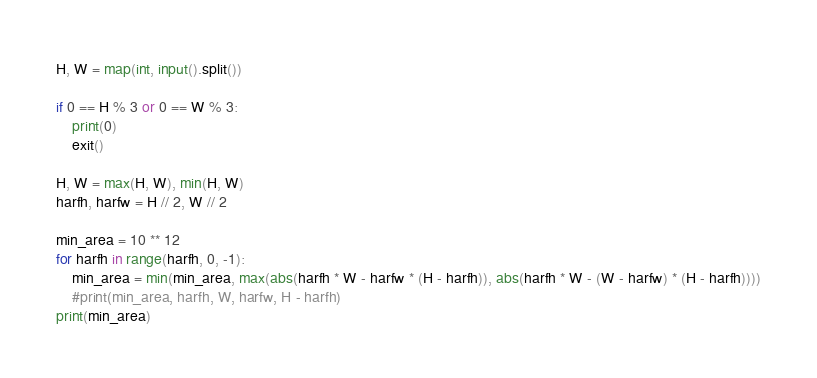Convert code to text. <code><loc_0><loc_0><loc_500><loc_500><_Python_>H, W = map(int, input().split())

if 0 == H % 3 or 0 == W % 3:
	print(0)
	exit()

H, W = max(H, W), min(H, W)
harfh, harfw = H // 2, W // 2

min_area = 10 ** 12
for harfh in range(harfh, 0, -1):
	min_area = min(min_area, max(abs(harfh * W - harfw * (H - harfh)), abs(harfh * W - (W - harfw) * (H - harfh))))
	#print(min_area, harfh, W, harfw, H - harfh)
print(min_area)
</code> 